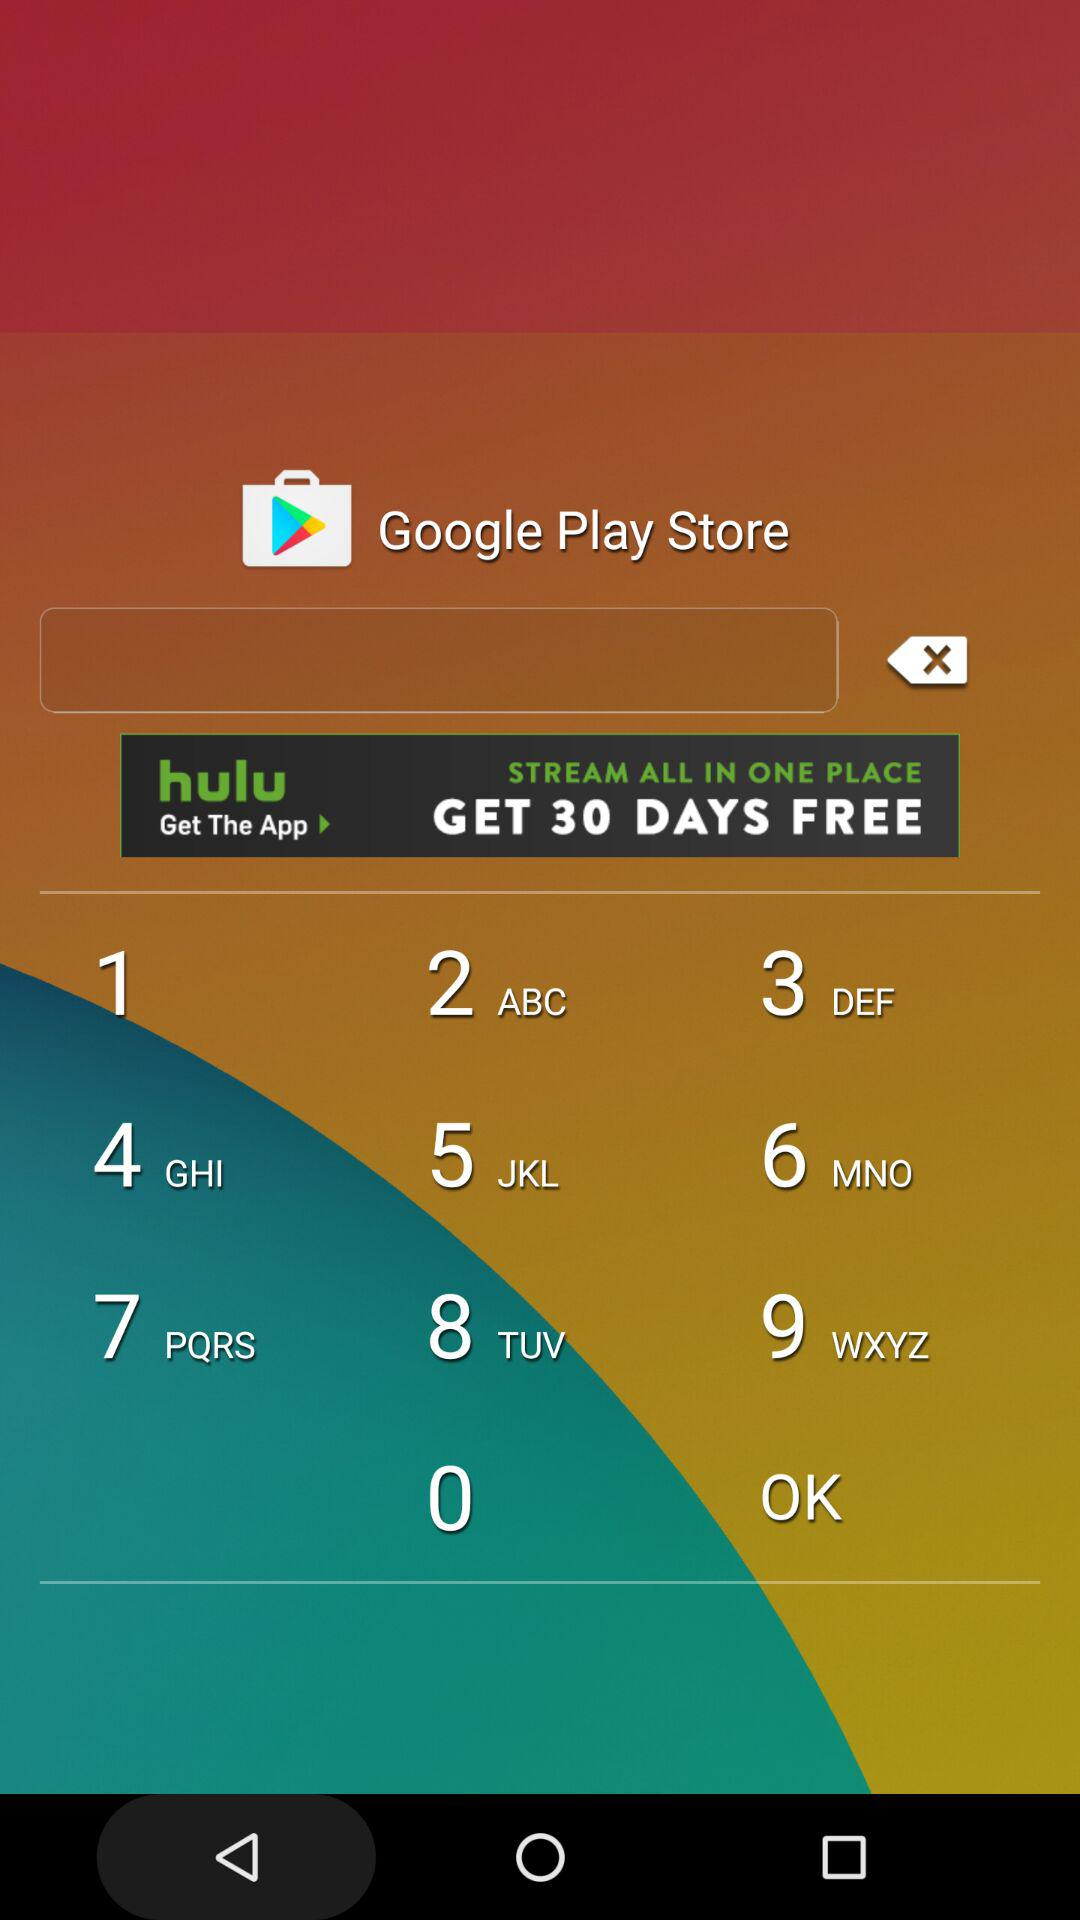Which race is scheduled for 12:49 PM? The race, which is scheduled for 12:49 PM, is Maiden Claiming. 